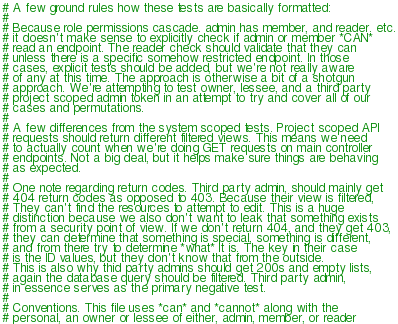Convert code to text. <code><loc_0><loc_0><loc_500><loc_500><_YAML_># A few ground rules how these tests are basically formatted:
#
# Because role permissions cascade. admin has member, and reader. etc.
# it doesn't make sense to explicitly check if admin or member *CAN*
# read an endpoint. The reader check should validate that they can
# unless there is a specific somehow restricted endpoint. In those
# cases, explicit tests should be added, but we're not really aware
# of any at this time. The approach is otherwise a bit of a shotgun
# approach. We're attempting to test owner, lessee, and a third party
# project scoped admin token in an attempt to try and cover all of our
# cases and permutations.
#
# A few differences from the system scoped tests. Project scoped API
# requests should return different filtered views. This means we need
# to actually count when we're doing GET requests on main controller
# endpoints. Not a big deal, but it helps make sure things are behaving
# as expected.
#
# One note regarding return codes. Third party admin, should mainly get
# 404 return codes as opposed to 403. Because their view is filtered,
# They can't find the resources to attempt to edit. This is a huge
# distinction because we also don't want to leak that something exists
# from a security point of view. If we don't return 404, and they get 403,
# they can determine that something is special, something is different,
# and from there try to determine *what* it is. The key in their case
# is the ID values, but they don't know that from the outside.
# This is also why thid party admins should get 200s and empty lists,
# again the database query should be filtered. Third party admin,
# in essence serves as the primary negative test.
#
# Conventions. This file uses *can* and *cannot* along with the
# personal, an owner or lessee of either, admin, member, or reader</code> 